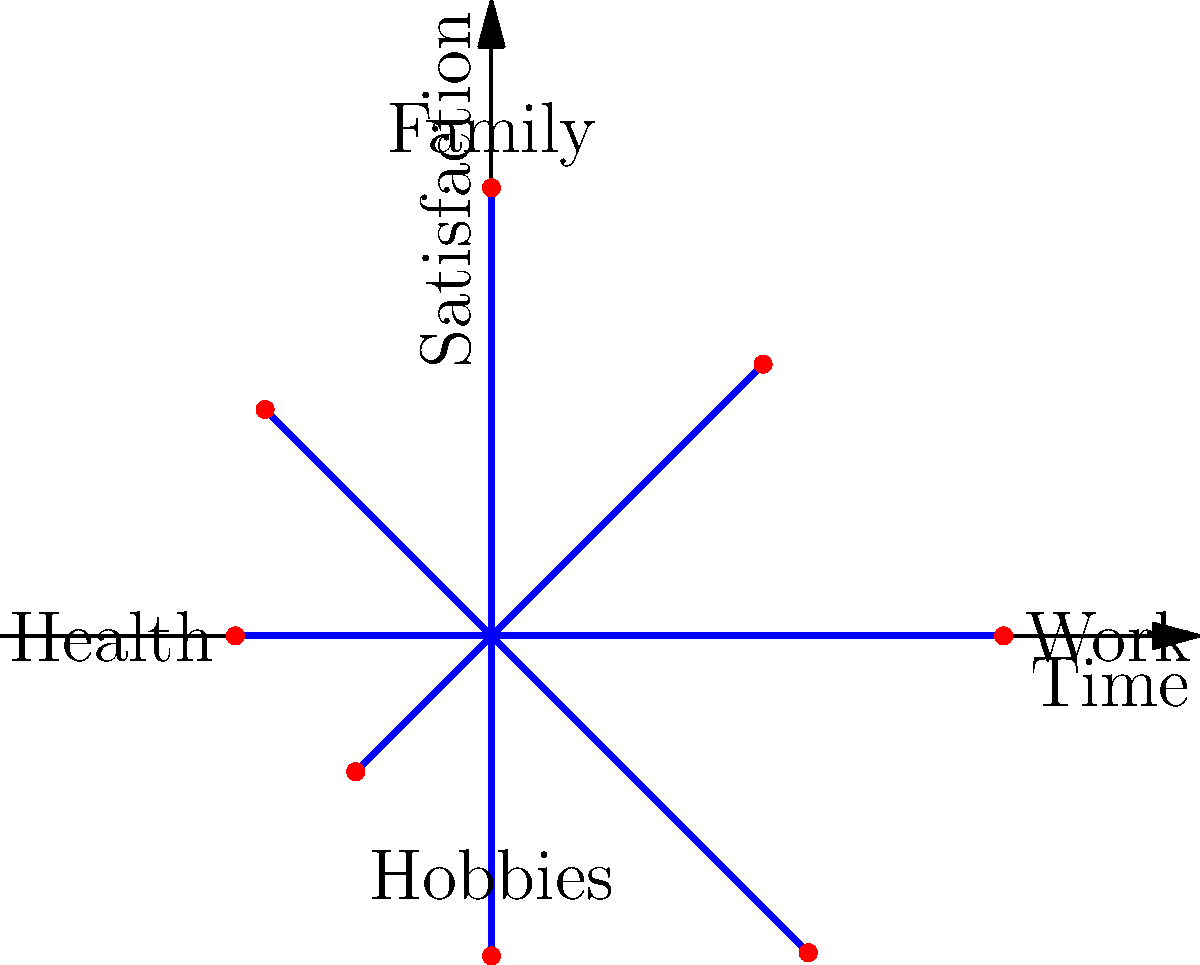In the polar coordinate representation of work-life balance satisfaction, which aspect shows the highest level of satisfaction, and how might this inform your decision for a second career that aligns with your passions? To answer this question, we need to analyze the polar coordinate graph:

1. The graph represents four key aspects of work-life balance: Work, Family, Health, and Hobbies.
2. Each aspect is plotted on a scale from 0 (center) to 8 (outer edge).
3. The longer the line from the center, the higher the satisfaction level.

Examining each aspect:
- Work: The line extends to 8, the maximum on the scale.
- Family: The line extends to about 7.
- Health: The line extends to about 4.
- Hobbies: The line extends to about 3.

Work shows the highest level of satisfaction, reaching the maximum of 8 on the scale.

For a former executive seeking a second career aligned with their passions:
1. The high work satisfaction suggests you derived significant fulfillment from your career.
2. Consider roles that leverage your executive experience while incorporating elements you found satisfying in your previous work.
3. Note the lower scores in Health and Hobbies, which might indicate areas for improvement in your new career choice.
4. Look for opportunities that maintain high work satisfaction while allowing more time for health and hobbies, potentially improving overall life balance.
5. The relatively high Family satisfaction (7) suggests maintaining work-family balance should be a priority in your new career.
Answer: Work shows highest satisfaction (8/8). Choose a second career leveraging executive skills and work elements you found fulfilling, while allowing more time for health and hobbies. 